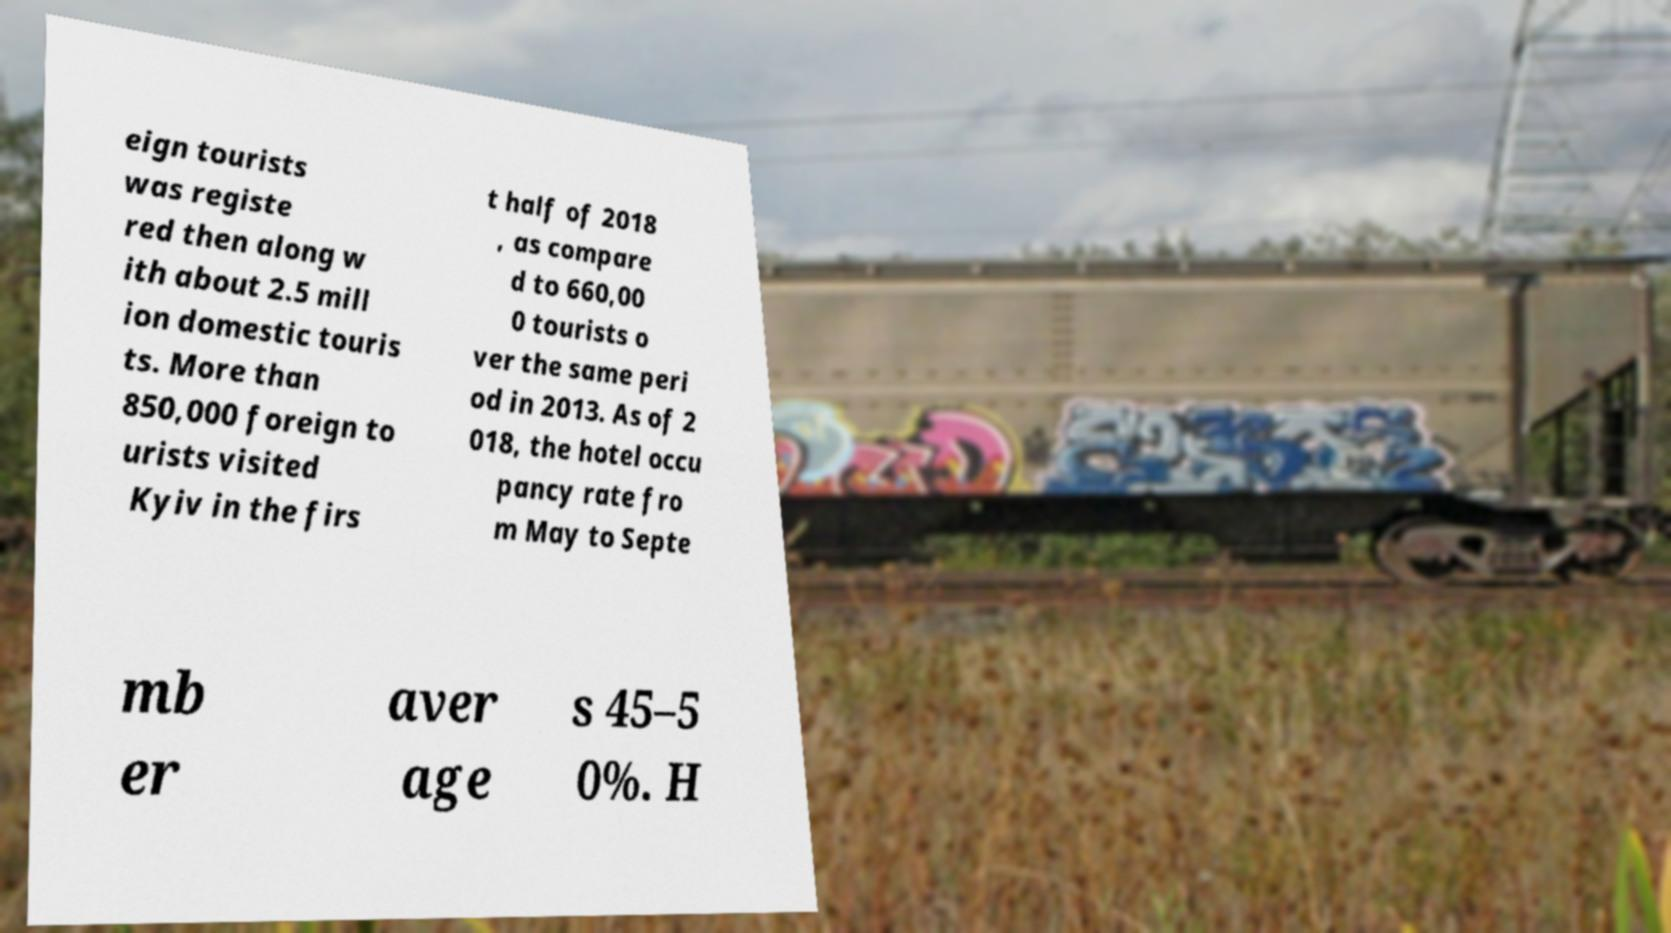Please read and relay the text visible in this image. What does it say? eign tourists was registe red then along w ith about 2.5 mill ion domestic touris ts. More than 850,000 foreign to urists visited Kyiv in the firs t half of 2018 , as compare d to 660,00 0 tourists o ver the same peri od in 2013. As of 2 018, the hotel occu pancy rate fro m May to Septe mb er aver age s 45–5 0%. H 